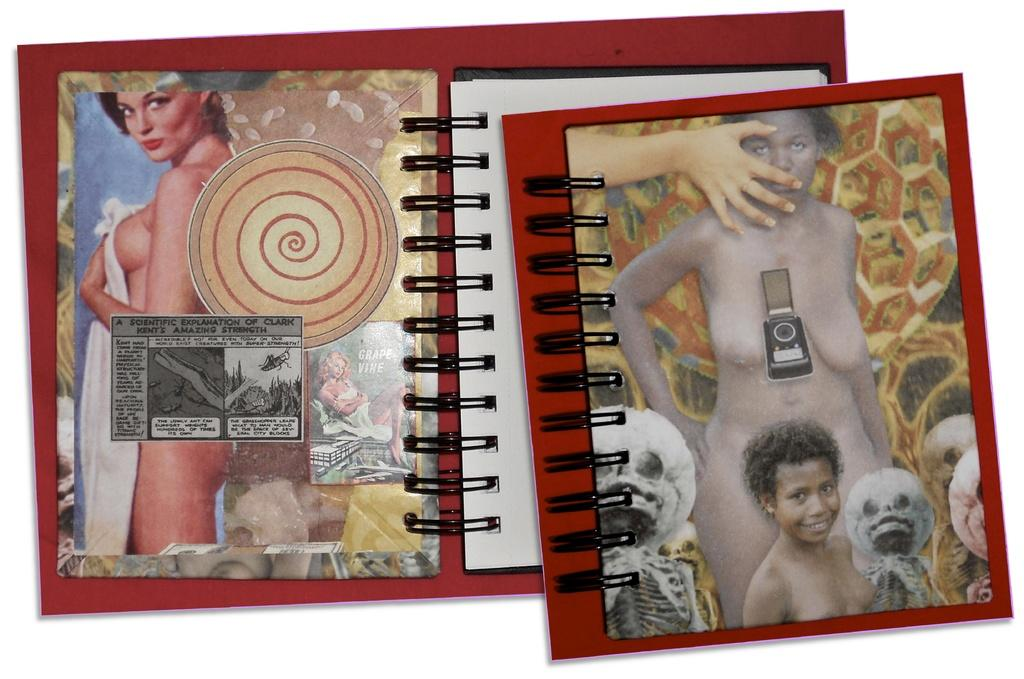What object is the main focus of the picture? There is an album in the picture. Can you describe the color of the album? The album is red. What type of content can be found in the album? There are women in the album. Is there anyone else present in the picture besides the album? Yes, there is a girl in the picture. What type of pet can be seen in the picture? There is no pet visible in the picture; it features an album and a girl. What relation does the girl have to the women in the album? The provided facts do not give any information about the relationship between the girl and the women in the album. 